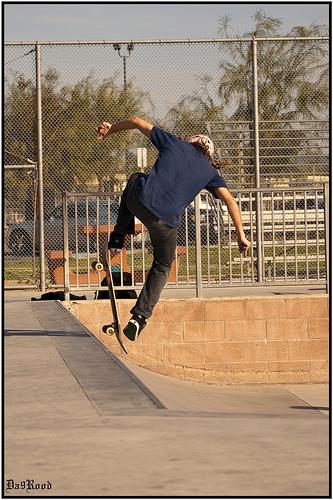Is there a car in the background?
Answer briefly. Yes. Is this skateboarding on the street?
Keep it brief. No. How many people are in this photo?
Quick response, please. 1. 